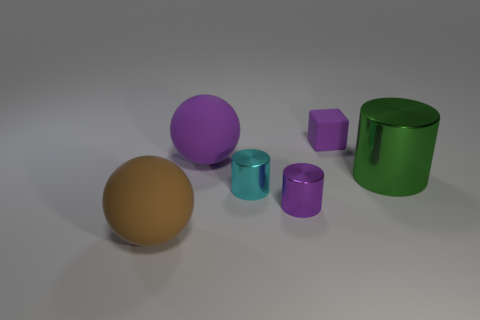Is there any other thing that is the same shape as the tiny purple matte object?
Provide a succinct answer. No. What number of other things are the same shape as the small purple metallic thing?
Your answer should be compact. 2. Do the big rubber object that is right of the brown thing and the large object right of the big purple rubber ball have the same color?
Offer a terse response. No. What is the size of the metal thing that is right of the tiny thing behind the purple ball to the right of the brown object?
Your response must be concise. Large. There is a object that is on the left side of the cyan metal cylinder and in front of the green metallic cylinder; what shape is it?
Provide a succinct answer. Sphere. Are there the same number of cyan metal objects that are in front of the brown sphere and large purple rubber spheres that are in front of the big green metal object?
Your answer should be compact. Yes. Is there a tiny cyan cylinder made of the same material as the purple cube?
Provide a short and direct response. No. Does the cylinder that is in front of the cyan metal object have the same material as the big purple thing?
Offer a very short reply. No. There is a thing that is left of the cyan metal thing and behind the brown rubber sphere; what size is it?
Offer a very short reply. Large. The tiny matte block is what color?
Keep it short and to the point. Purple. 